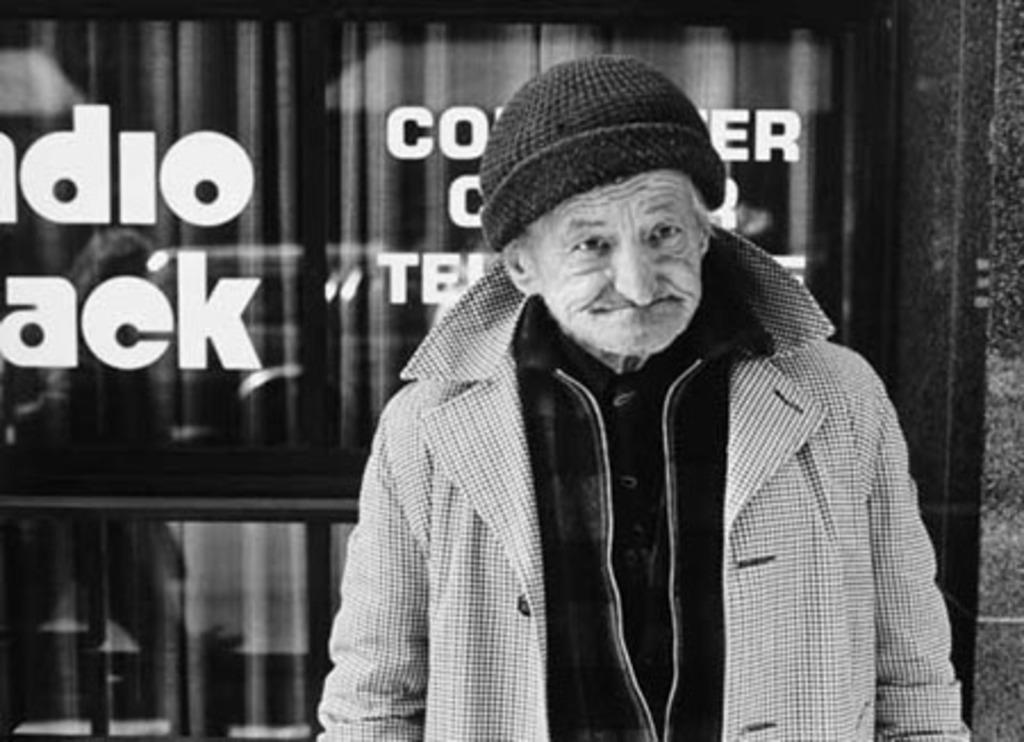What can be seen in the image? There is a person in the image. What is the person wearing? The person is wearing a jacket and a cap. What is visible in the background of the image? There is a glass wall in the background of the image. What is written on the glass wall? Something is written on the glass wall, but the specific text is not mentioned in the facts. How is the image presented? The image is in black and white. Can you see the person smiling in the image? The facts provided do not mention the person's facial expression, so it cannot be determined if they are smiling or not. 